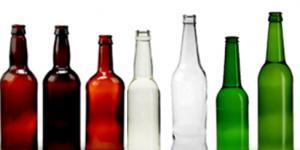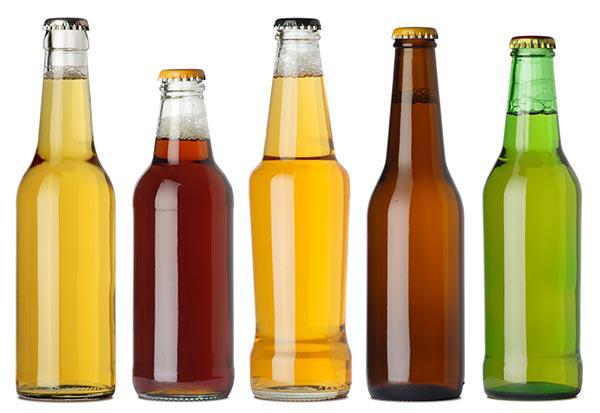The first image is the image on the left, the second image is the image on the right. For the images shown, is this caption "The bottles are of two colors and none have lables." true? Answer yes or no. No. The first image is the image on the left, the second image is the image on the right. Examine the images to the left and right. Is the description "No bottles have labels or metal openers on top." accurate? Answer yes or no. Yes. 